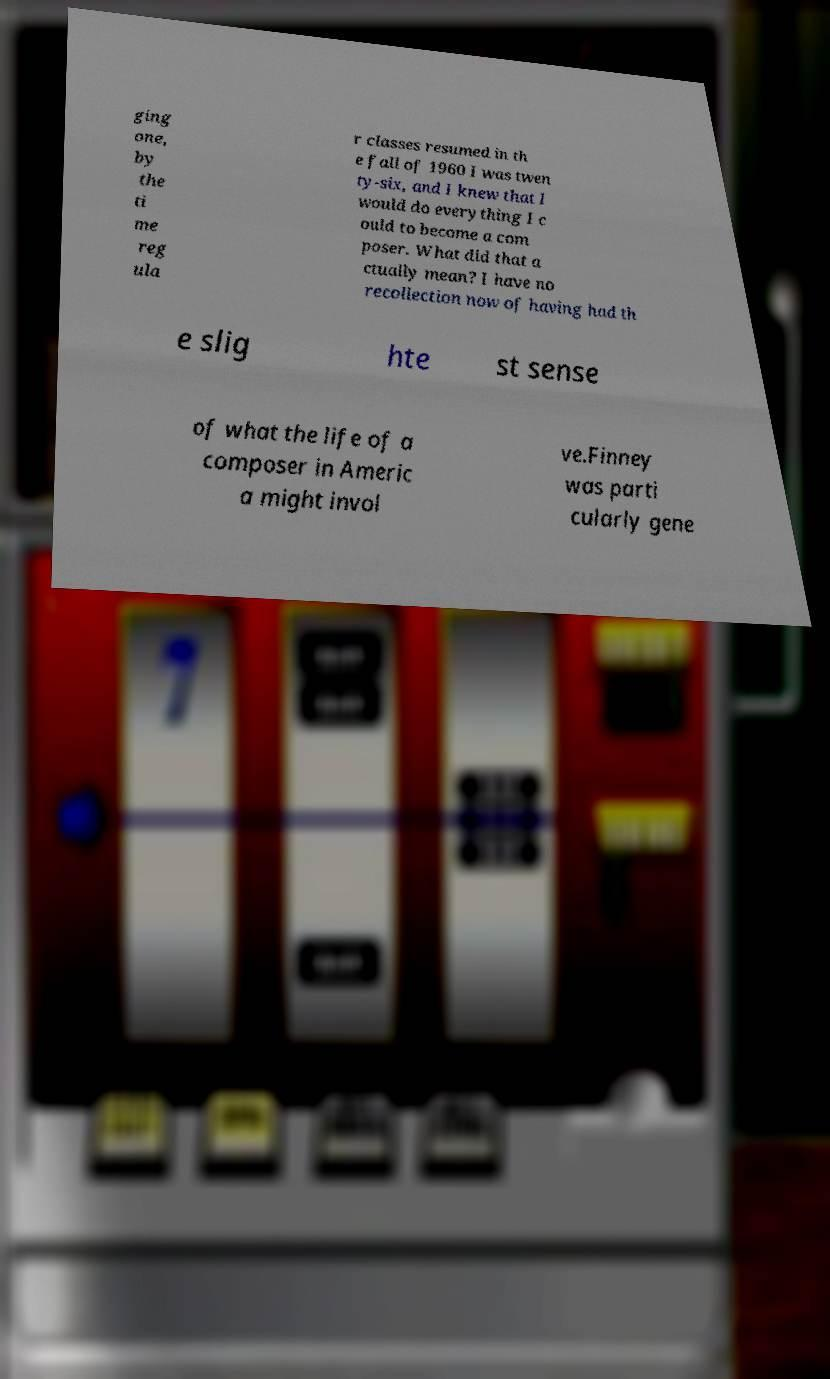I need the written content from this picture converted into text. Can you do that? ging one, by the ti me reg ula r classes resumed in th e fall of 1960 I was twen ty-six, and I knew that I would do everything I c ould to become a com poser. What did that a ctually mean? I have no recollection now of having had th e slig hte st sense of what the life of a composer in Americ a might invol ve.Finney was parti cularly gene 